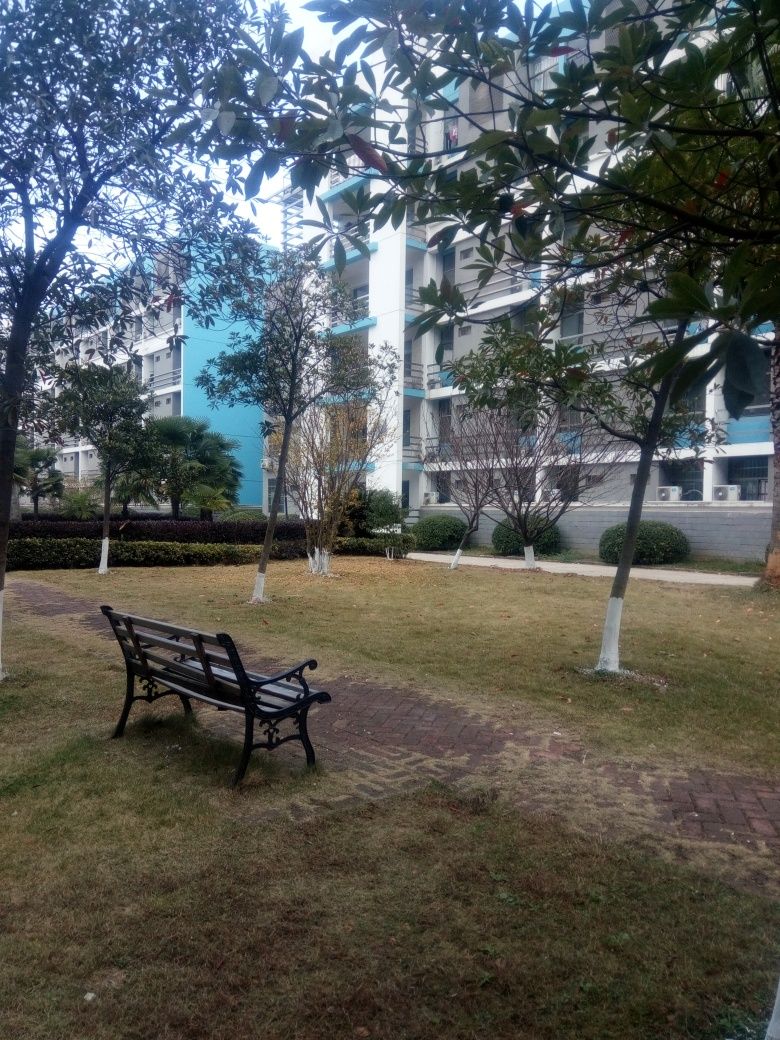What is the overall clarity of the image?
A. Acceptable
B. Poor
C. Blurry The overall clarity of the image falls into the 'Acceptable' category. Despite the complexity of the outdoor scene, details such as the texture of the bench, the foliage, and the building facades are relatively clear. Certain areas, particularly those in shadow, might present a slightly lower level of detail but this does not significantly affect the overall legibility of the image. 